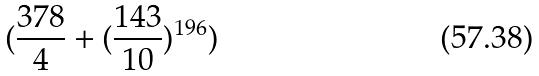Convert formula to latex. <formula><loc_0><loc_0><loc_500><loc_500>( \frac { 3 7 8 } { 4 } + ( \frac { 1 4 3 } { 1 0 } ) ^ { 1 9 6 } )</formula> 